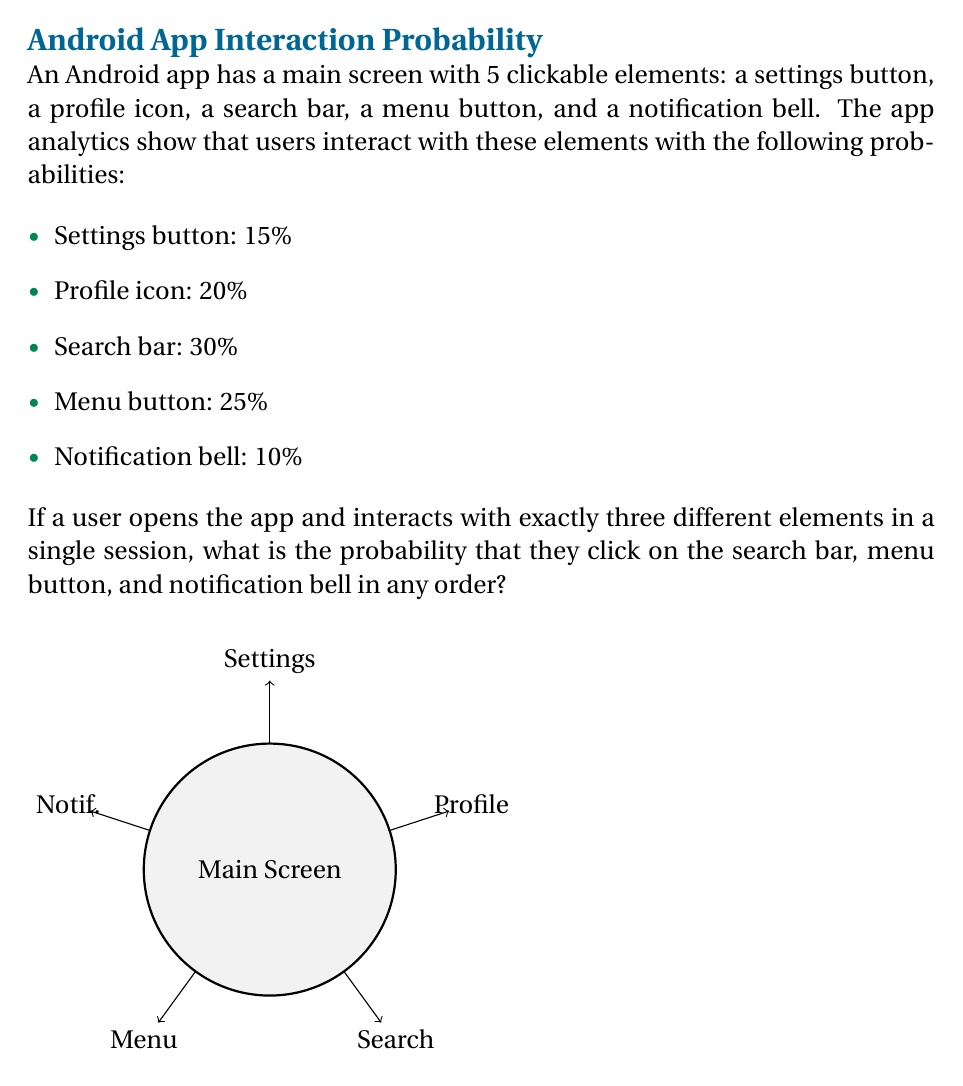Can you solve this math problem? Let's approach this step-by-step:

1) First, we need to calculate the probability of selecting these three specific elements out of the five available. This is a combination problem, but since we're given the specific elements, we just need to multiply their individual probabilities.

2) The probabilities for the required elements are:
   - Search bar: 30% = 0.30
   - Menu button: 25% = 0.25
   - Notification bell: 10% = 0.10

3) However, the question states "in any order". This means we need to consider all possible orders of clicking these three elements. There are 3! = 6 possible orders.

4) The probability of clicking these three elements in a specific order is:

   $$ P(\text{specific order}) = 0.30 \times 0.25 \times 0.10 = 0.0075 $$

5) Since any of the 6 possible orders is acceptable, we multiply this probability by 6:

   $$ P(\text{any order}) = 6 \times 0.0075 = 0.045 $$

6) Therefore, the probability of a user clicking on the search bar, menu button, and notification bell in any order during a single session with exactly three interactions is 0.045 or 4.5%.
Answer: 0.045 